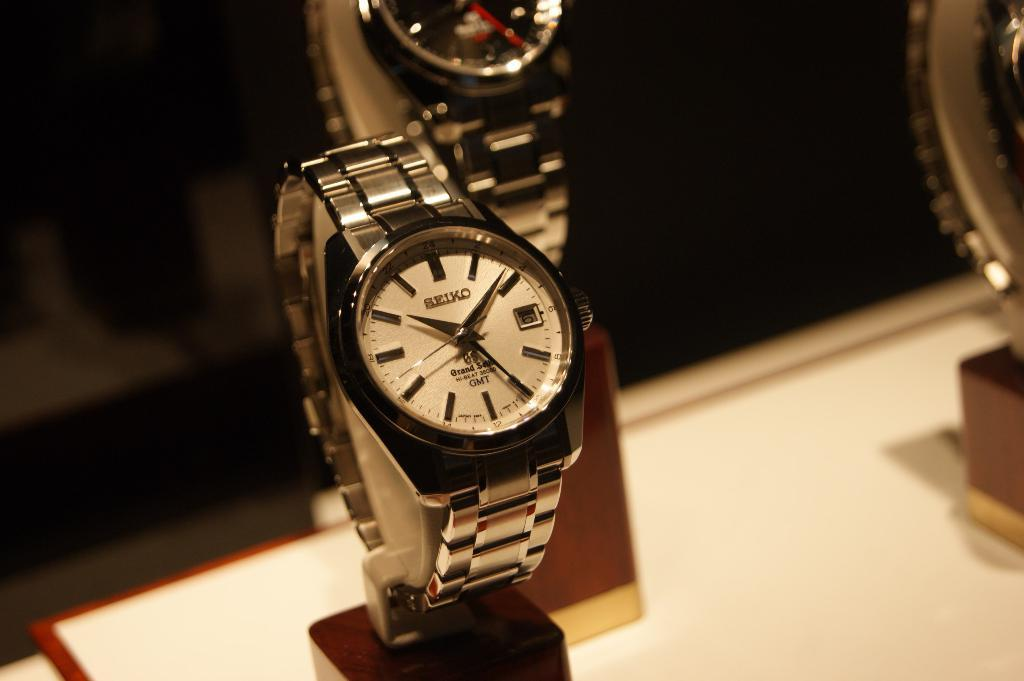<image>
Write a terse but informative summary of the picture. A watch which has the word Seiko on the face. 